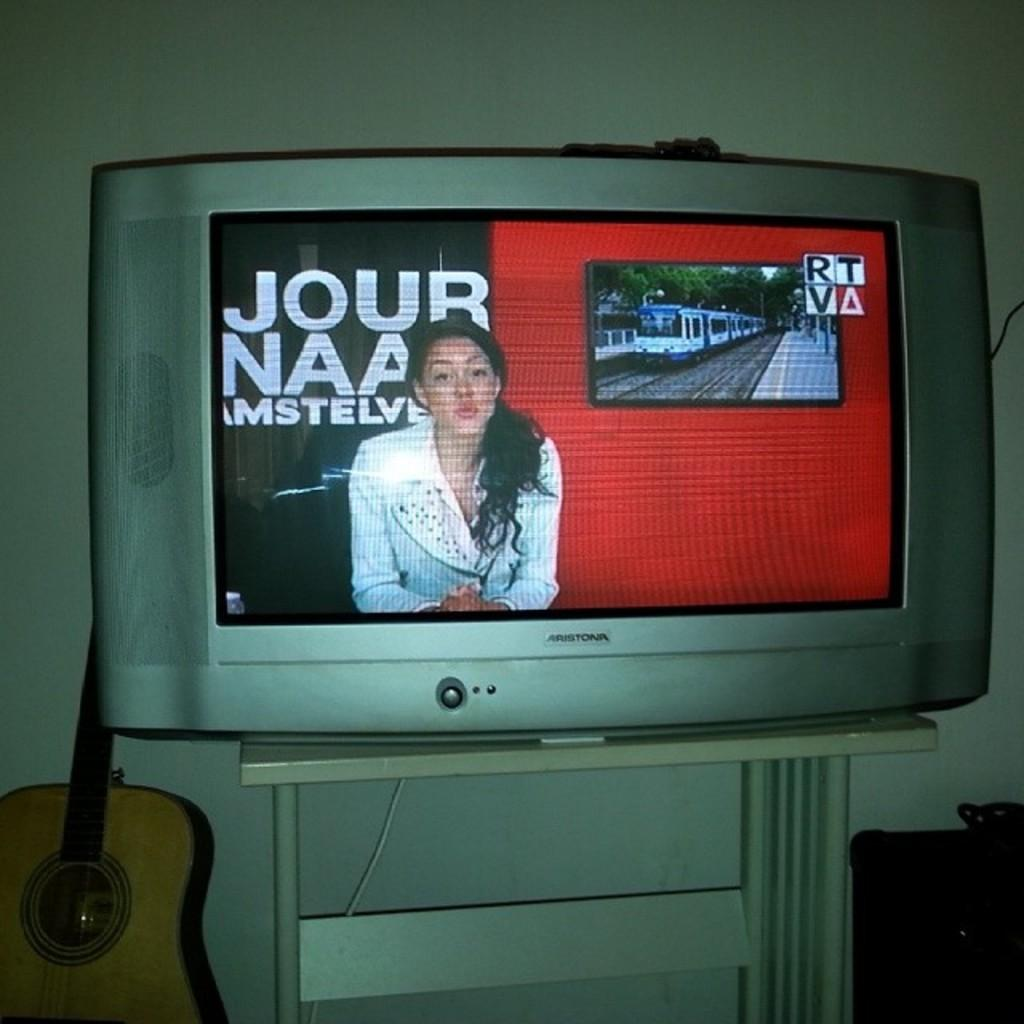<image>
Present a compact description of the photo's key features. A woman displayed on the screen sits in front of a sign that has Jour in yellow letters. 